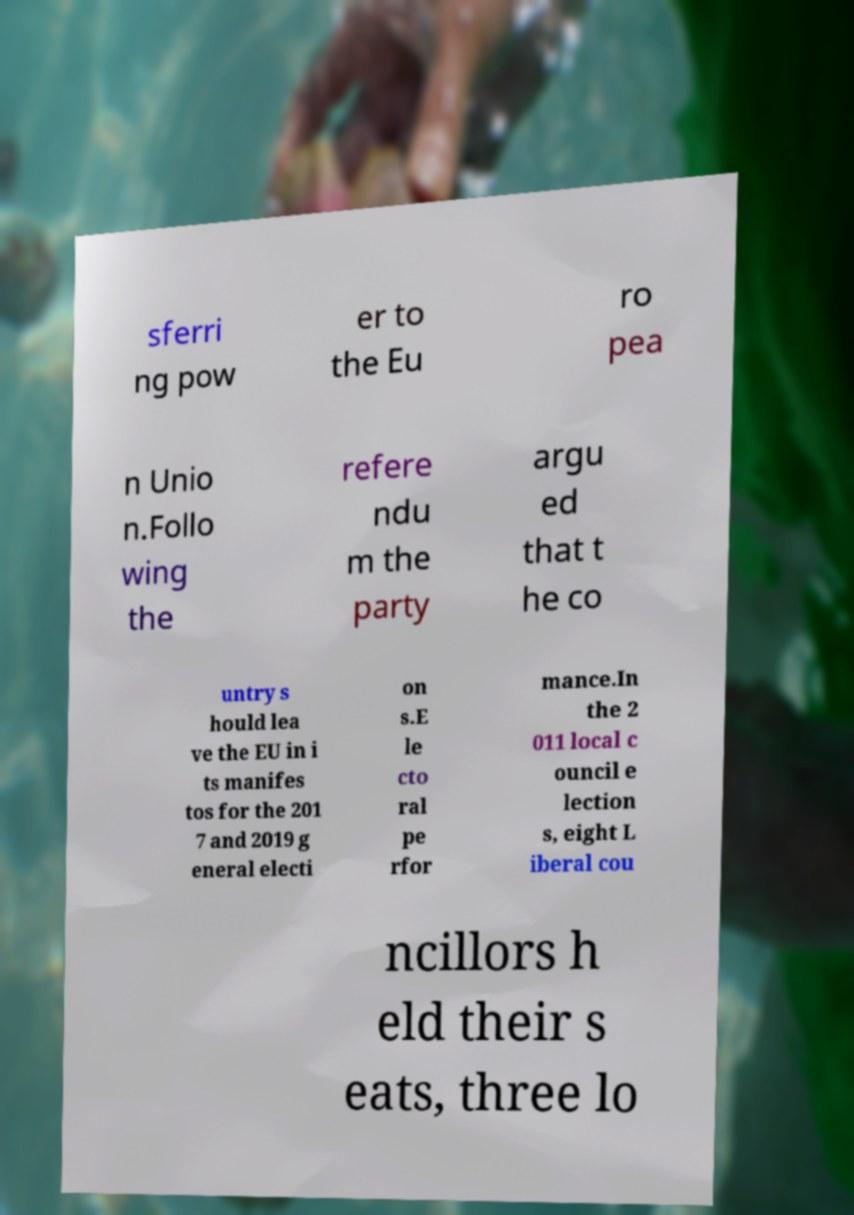Please read and relay the text visible in this image. What does it say? sferri ng pow er to the Eu ro pea n Unio n.Follo wing the refere ndu m the party argu ed that t he co untry s hould lea ve the EU in i ts manifes tos for the 201 7 and 2019 g eneral electi on s.E le cto ral pe rfor mance.In the 2 011 local c ouncil e lection s, eight L iberal cou ncillors h eld their s eats, three lo 